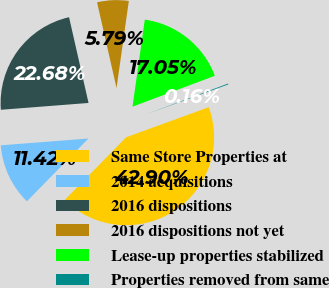Convert chart. <chart><loc_0><loc_0><loc_500><loc_500><pie_chart><fcel>Same Store Properties at<fcel>2014 acquisitions<fcel>2016 dispositions<fcel>2016 dispositions not yet<fcel>Lease-up properties stabilized<fcel>Properties removed from same<nl><fcel>42.9%<fcel>11.42%<fcel>22.68%<fcel>5.79%<fcel>17.05%<fcel>0.16%<nl></chart> 